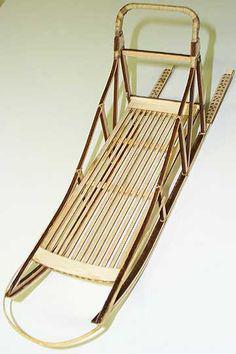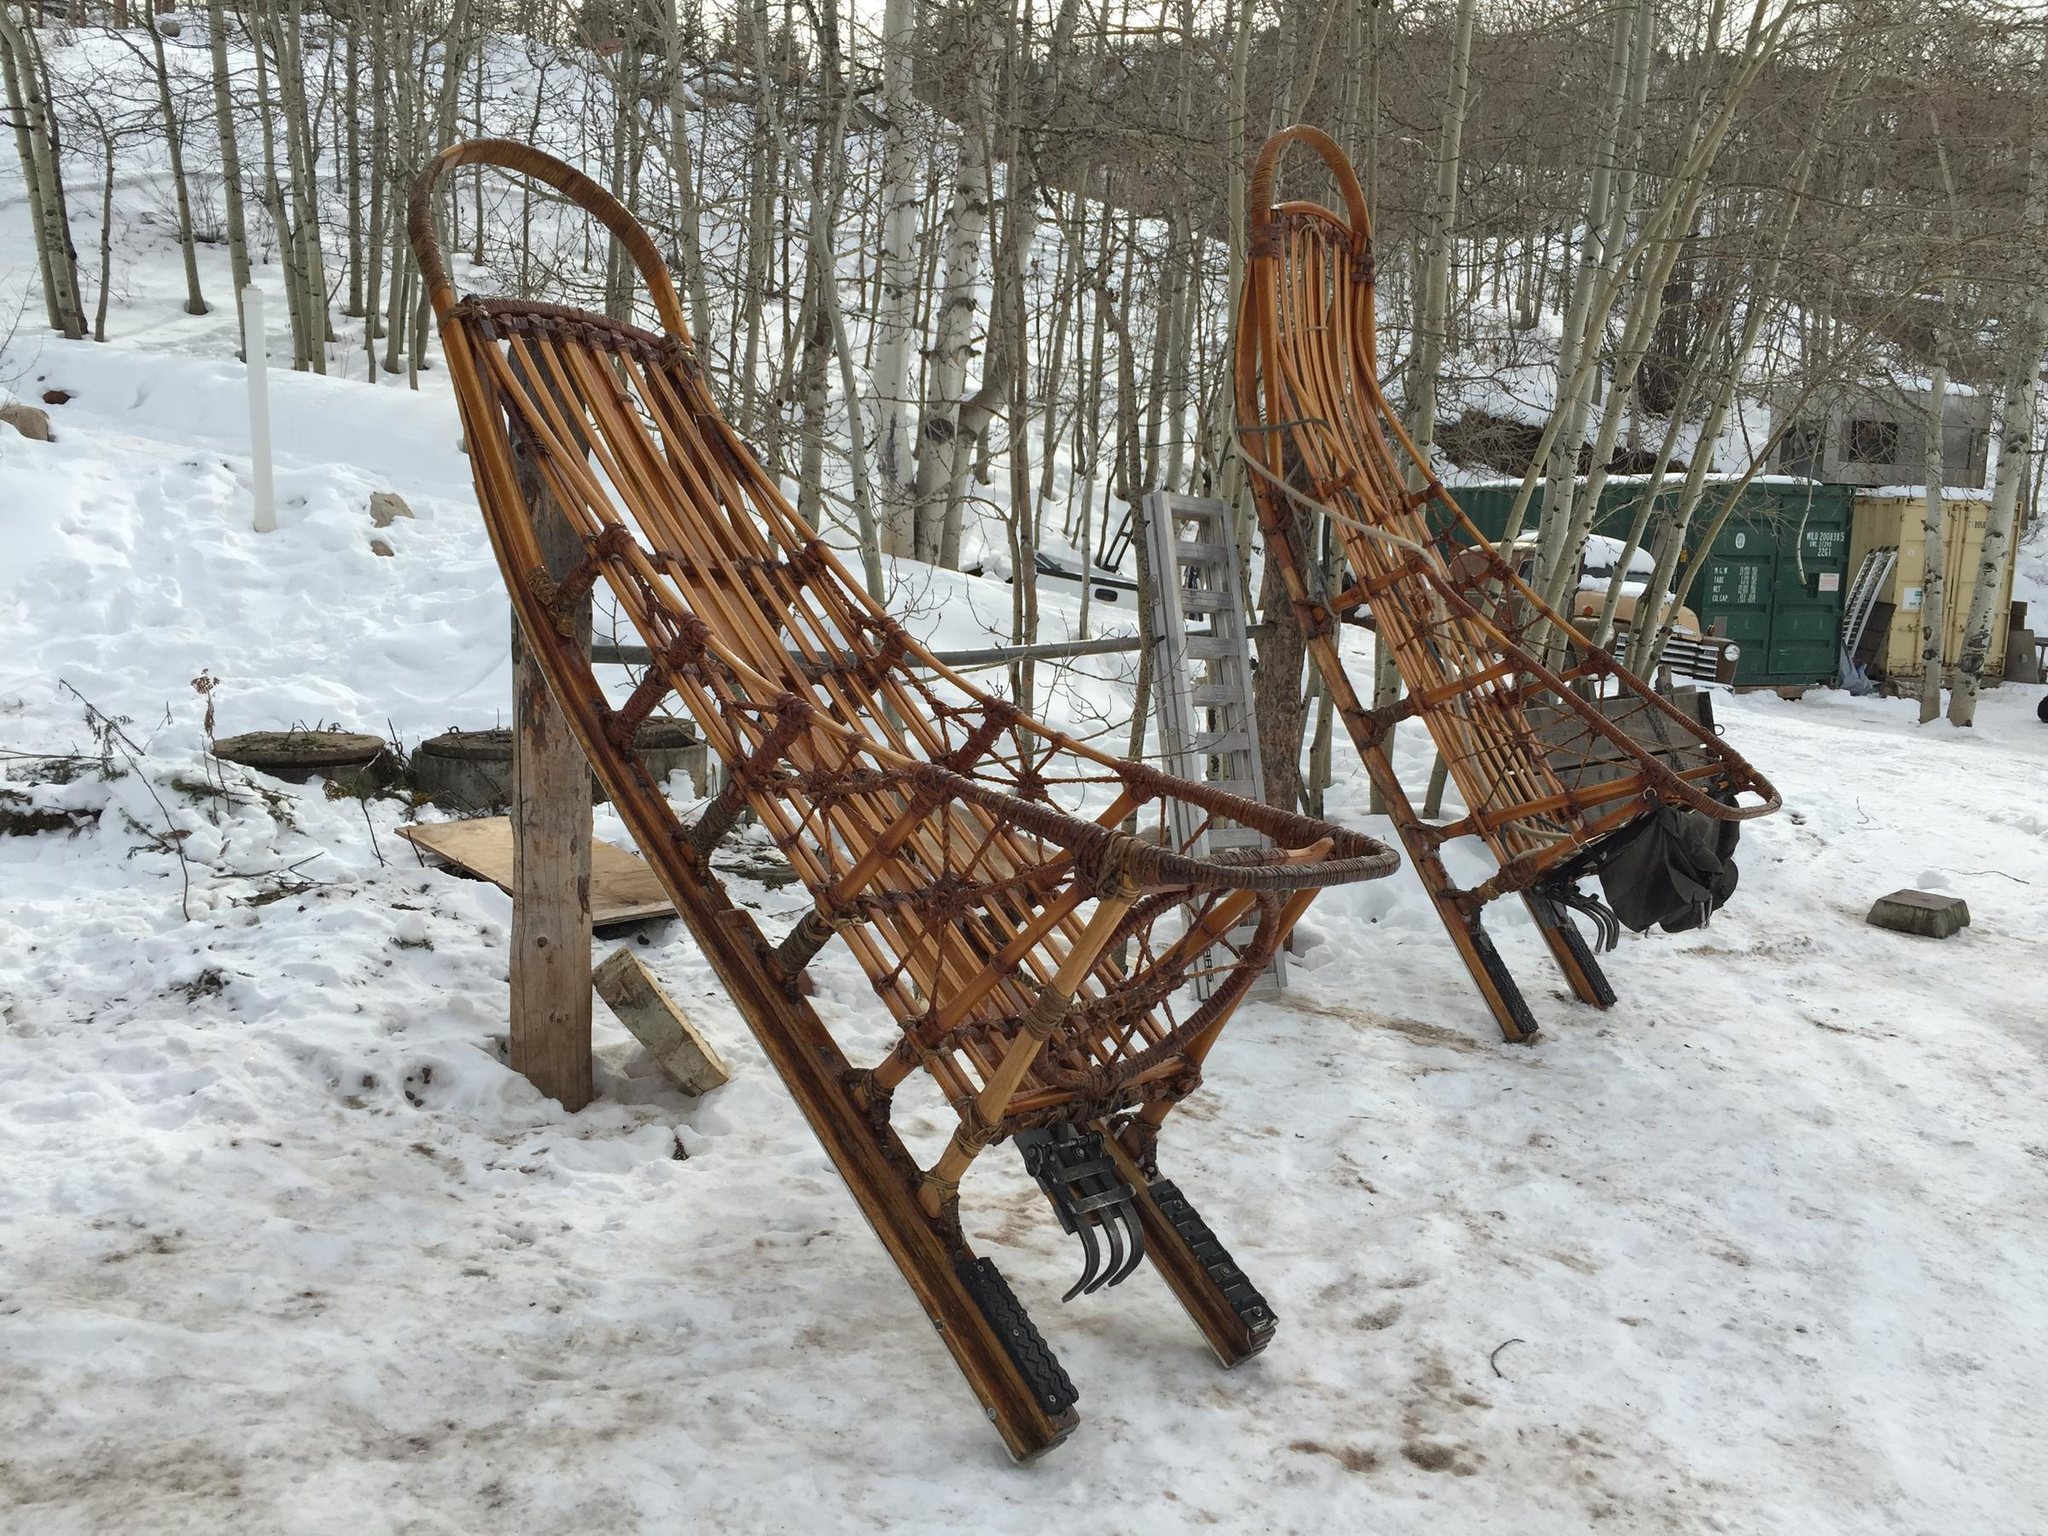The first image is the image on the left, the second image is the image on the right. Given the left and right images, does the statement "The left image contains exactly one male human." hold true? Answer yes or no. No. The first image is the image on the left, the second image is the image on the right. For the images shown, is this caption "There is a human looking at a sled in one of the images." true? Answer yes or no. No. 